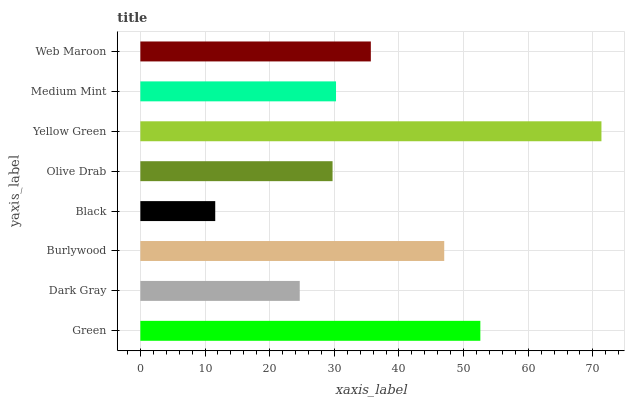Is Black the minimum?
Answer yes or no. Yes. Is Yellow Green the maximum?
Answer yes or no. Yes. Is Dark Gray the minimum?
Answer yes or no. No. Is Dark Gray the maximum?
Answer yes or no. No. Is Green greater than Dark Gray?
Answer yes or no. Yes. Is Dark Gray less than Green?
Answer yes or no. Yes. Is Dark Gray greater than Green?
Answer yes or no. No. Is Green less than Dark Gray?
Answer yes or no. No. Is Web Maroon the high median?
Answer yes or no. Yes. Is Medium Mint the low median?
Answer yes or no. Yes. Is Medium Mint the high median?
Answer yes or no. No. Is Web Maroon the low median?
Answer yes or no. No. 